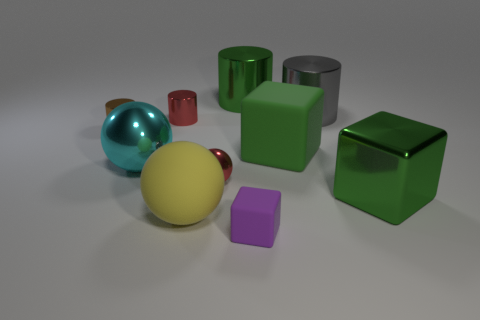Subtract all tiny matte blocks. How many blocks are left? 2 Subtract 0 blue spheres. How many objects are left? 10 Subtract all cubes. How many objects are left? 7 Subtract 3 cylinders. How many cylinders are left? 1 Subtract all brown cylinders. Subtract all cyan blocks. How many cylinders are left? 3 Subtract all yellow spheres. How many brown cylinders are left? 1 Subtract all brown shiny things. Subtract all tiny cylinders. How many objects are left? 7 Add 2 red metallic cylinders. How many red metallic cylinders are left? 3 Add 7 cyan spheres. How many cyan spheres exist? 8 Subtract all green blocks. How many blocks are left? 1 